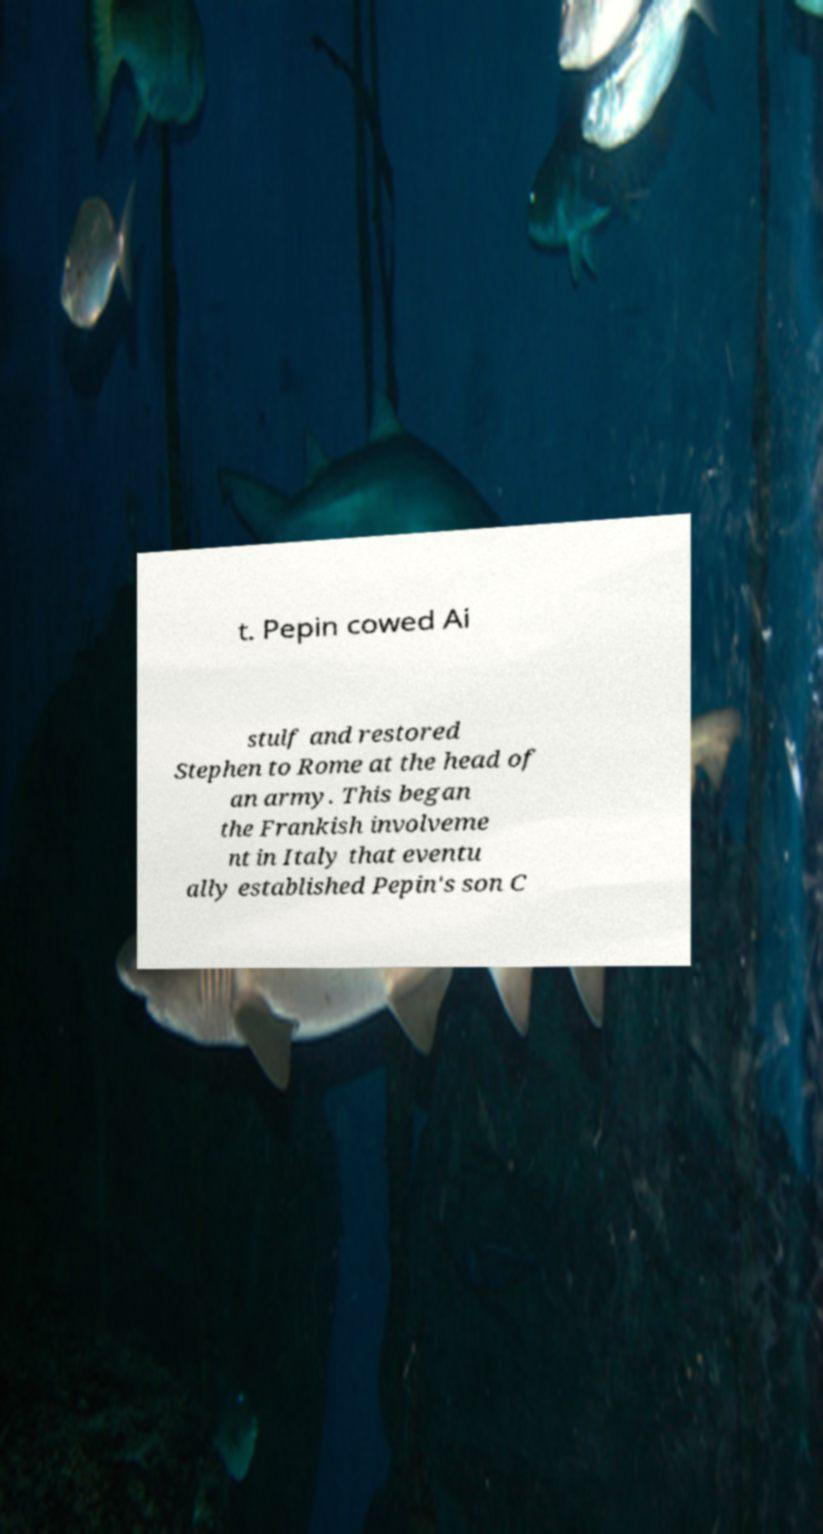Please read and relay the text visible in this image. What does it say? t. Pepin cowed Ai stulf and restored Stephen to Rome at the head of an army. This began the Frankish involveme nt in Italy that eventu ally established Pepin's son C 